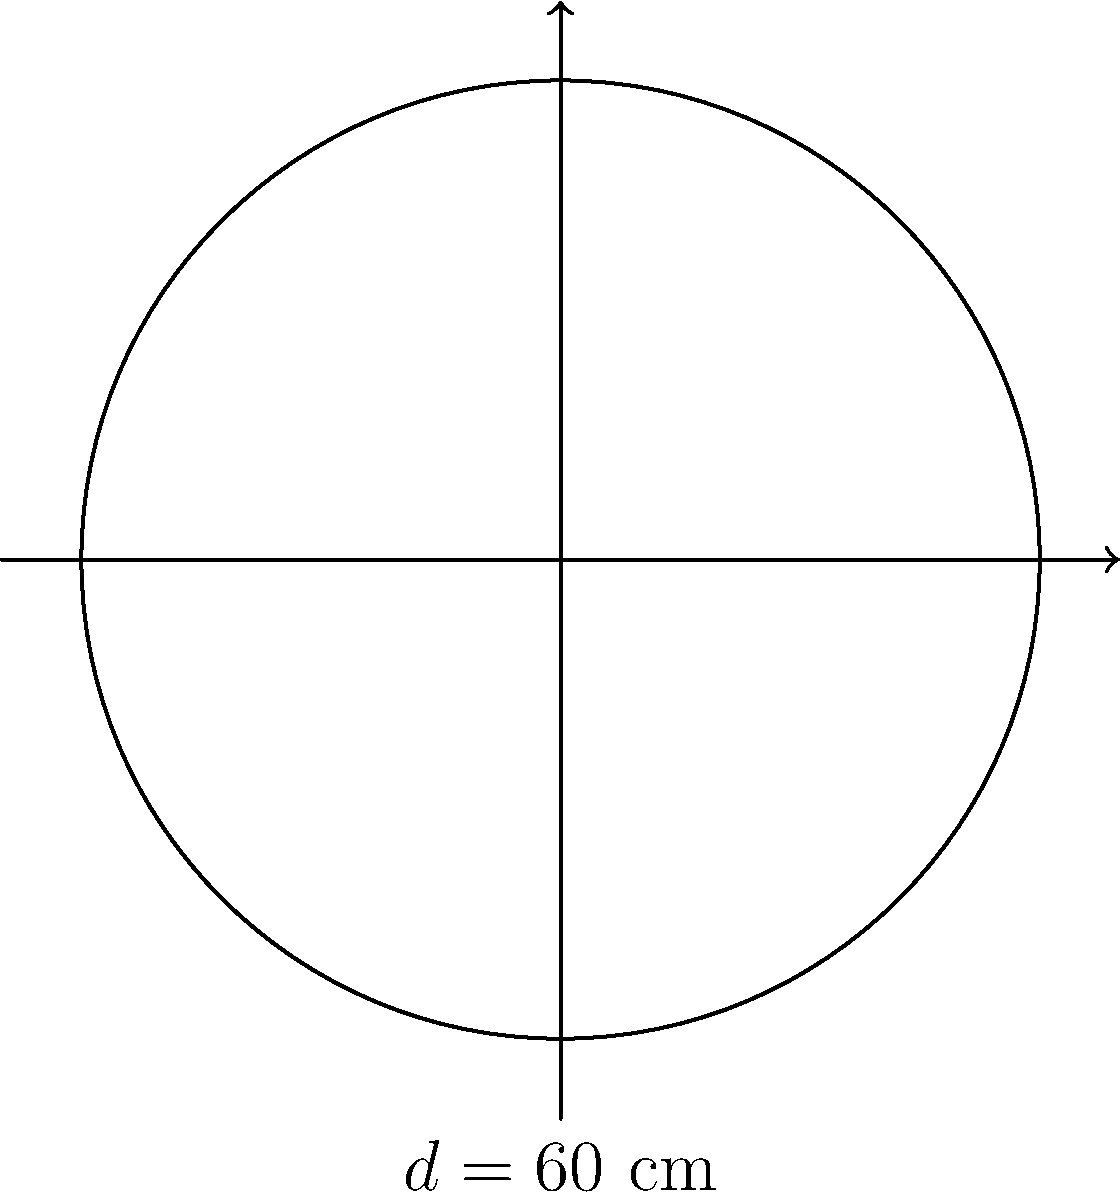As a cloth diaper enthusiast, you've decided to make a circular changing pad for your nursery. If the diameter of the pad is 60 cm, what is the circumference of the changing pad? To find the circumference of a circular changing pad, we can follow these steps:

1. Recall the formula for the circumference of a circle:
   $$C = \pi d$$
   where $C$ is the circumference, $\pi$ is pi (approximately 3.14159), and $d$ is the diameter.

2. We are given the diameter $d = 60$ cm.

3. Substitute the values into the formula:
   $$C = \pi \times 60\text{ cm}$$

4. Calculate:
   $$C \approx 3.14159 \times 60\text{ cm} = 188.4954\text{ cm}$$

5. Round to a practical measurement (nearest cm):
   $$C \approx 188\text{ cm}$$

This circumference represents the length of fabric you'd need to create an edge binding for your circular changing pad.
Answer: $188\text{ cm}$ 